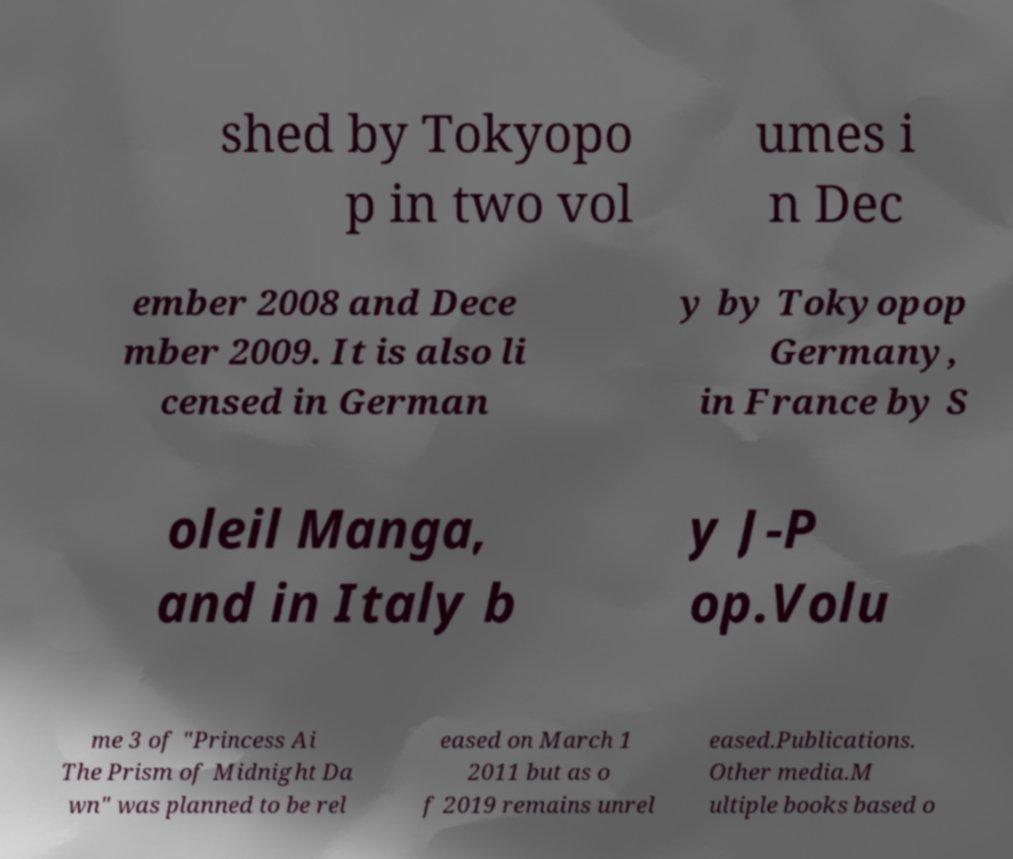Please identify and transcribe the text found in this image. shed by Tokyopo p in two vol umes i n Dec ember 2008 and Dece mber 2009. It is also li censed in German y by Tokyopop Germany, in France by S oleil Manga, and in Italy b y J-P op.Volu me 3 of "Princess Ai The Prism of Midnight Da wn" was planned to be rel eased on March 1 2011 but as o f 2019 remains unrel eased.Publications. Other media.M ultiple books based o 